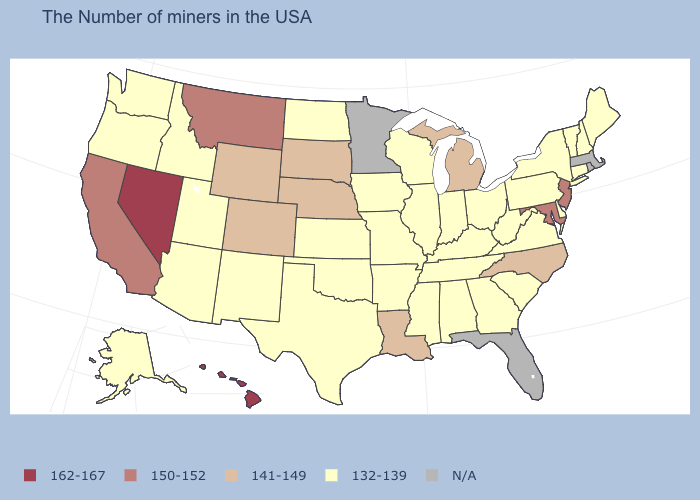Does Maine have the lowest value in the USA?
Give a very brief answer. Yes. Name the states that have a value in the range 141-149?
Write a very short answer. North Carolina, Michigan, Louisiana, Nebraska, South Dakota, Wyoming, Colorado. Is the legend a continuous bar?
Concise answer only. No. What is the highest value in states that border Delaware?
Quick response, please. 150-152. What is the highest value in the USA?
Concise answer only. 162-167. What is the value of Michigan?
Keep it brief. 141-149. What is the value of Wisconsin?
Quick response, please. 132-139. Name the states that have a value in the range 162-167?
Be succinct. Nevada, Hawaii. Name the states that have a value in the range 141-149?
Give a very brief answer. North Carolina, Michigan, Louisiana, Nebraska, South Dakota, Wyoming, Colorado. What is the lowest value in states that border Delaware?
Write a very short answer. 132-139. Does the first symbol in the legend represent the smallest category?
Short answer required. No. What is the highest value in the USA?
Write a very short answer. 162-167. Which states have the lowest value in the MidWest?
Write a very short answer. Ohio, Indiana, Wisconsin, Illinois, Missouri, Iowa, Kansas, North Dakota. 